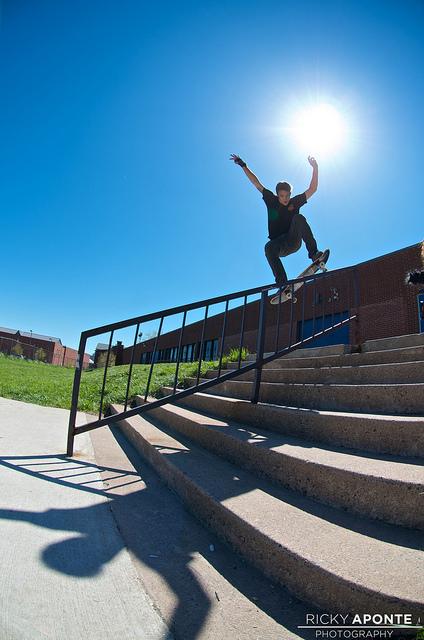Whose name is on the picture?
Write a very short answer. Ricky aponte. What color are the man's pants?
Concise answer only. Black. Is this person wearing any safety gear?
Quick response, please. No. 